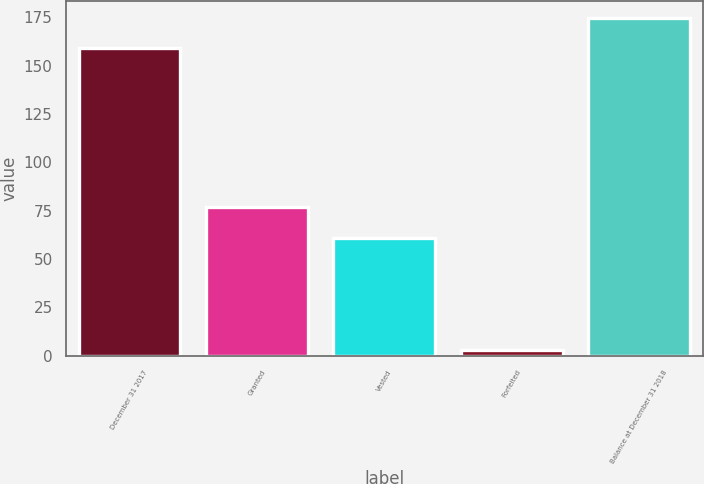Convert chart to OTSL. <chart><loc_0><loc_0><loc_500><loc_500><bar_chart><fcel>December 31 2017<fcel>Granted<fcel>Vested<fcel>Forfeited<fcel>Balance at December 31 2018<nl><fcel>159<fcel>76.9<fcel>61<fcel>3<fcel>174.9<nl></chart> 